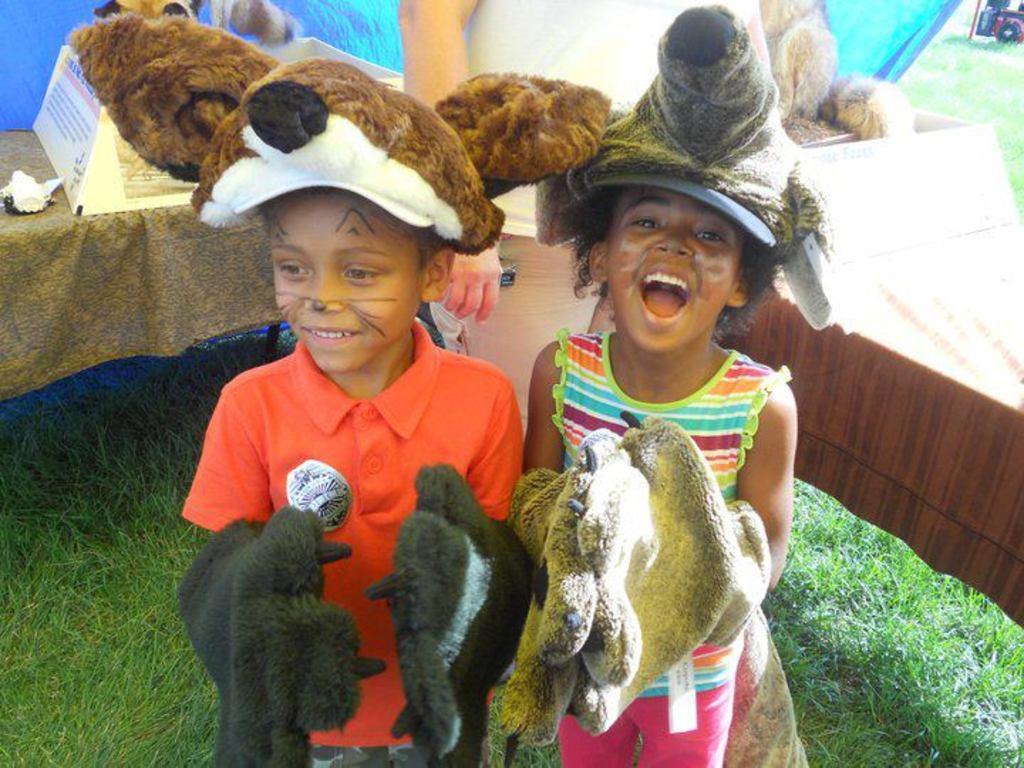Describe this image in one or two sentences. In this image I can see a boy wearing orange colored t shirt and a girl wearing colorful dress are standing and I can see they are wearing gloves. In the background I can see some grass, few toys, a blue colored sheet and a vehicle. 